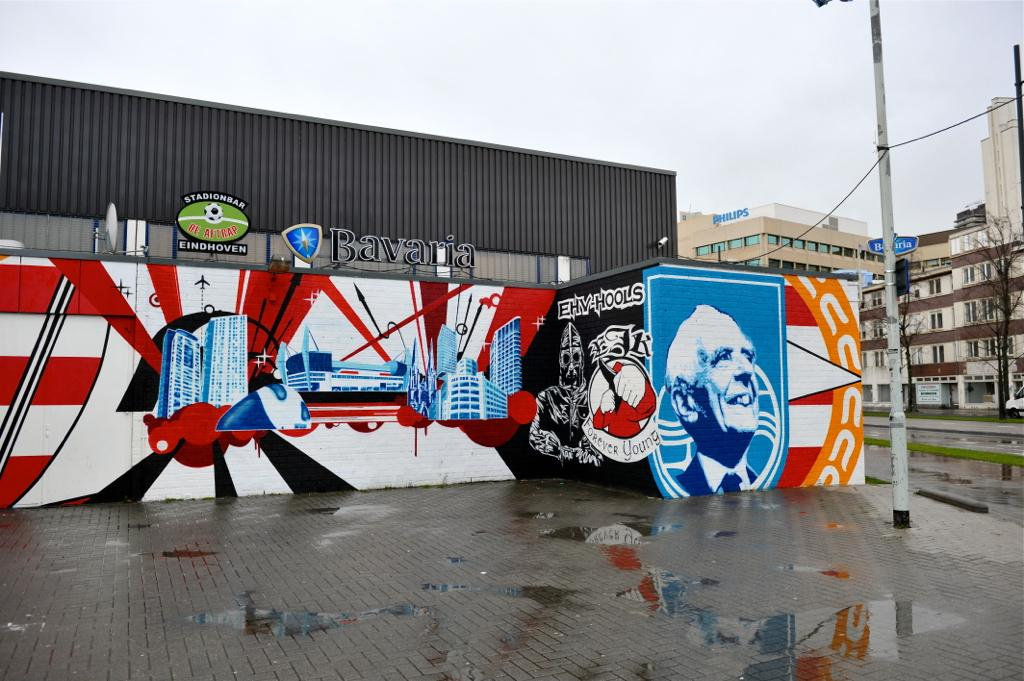What structures are located in the middle of the image? There are buildings in the middle of the image. What type of vegetation is on the right side of the image? There is a tree on the right side of the image. What is visible at the top of the image? The sky is visible at the top of the image. What type of lawyer is depicted in the image? There is no lawyer present in the image; it features buildings, a tree, and the sky. What season is represented in the image? The provided facts do not mention any specific season, so it cannot be determined from the image. 